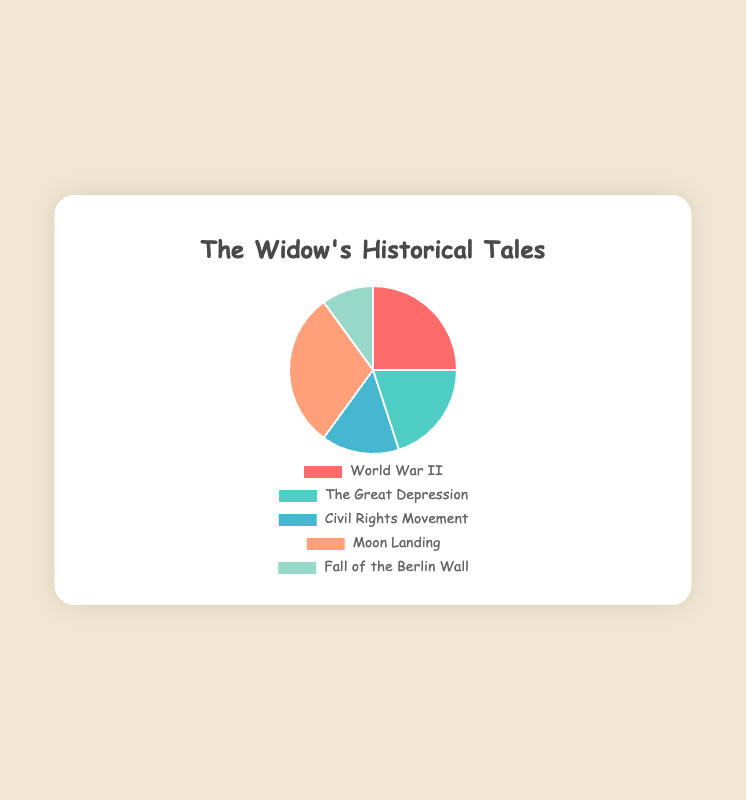Which historical event is most frequently discussed in the widow's stories? The figure shows a pie chart with the Moon Landing comprising the largest slice at 30%.
Answer: Moon Landing Which historical event is least frequently discussed in the widow's stories? The figure shows a pie chart with the Fall of the Berlin Wall comprising the smallest slice at 10%.
Answer: Fall of the Berlin Wall How much more frequently is the Moon Landing discussed compared to the Civil Rights Movement? The Moon Landing is 30% and the Civil Rights Movement is 15%. The difference is 30% - 15% = 15%.
Answer: 15% What is the combined percentage for stories about World War II and the Great Depression? World War II is 25% and the Great Depression is 20%. The combined percentage is 25% + 20% = 45%.
Answer: 45% Which two historical events are discussed equally, making up 50% of the stories? The Moon Landing is 30% and the Great Depression is 20%. Combined, they make 30% + 20% = 50%.
Answer: Moon Landing and Great Depression What is the average percentage of stories for all historical events? The percentages are 25%, 20%, 15%, 30%, and 10%. The sum is 100%. The average is 100% / 5 = 20%.
Answer: 20% How do the stories of the Civil Rights Movement compare to those of the Fall of the Berlin Wall in terms of frequency? The Civil Rights Movement is discussed 15% of the time, while the Fall of the Berlin Wall is discussed 10% of the time. The Civil Rights Movement is discussed more frequently by 5%.
Answer: Civil Rights Movement is 5% more Is the sum of the percentages for the stories about World War II and the Moon Landing greater than 50%? World War II is 25% and the Moon Landing is 30%. The sum is 25% + 30% = 55%, which is greater than 50%.
Answer: Yes What color represents the section for the Great Depression? The pie chart colors in order are: World War II (red), The Great Depression (teal green), Civil Rights Movement (blue), Moon Landing (light salmon), Fall of the Berlin Wall (pale green).
Answer: Teal green Which historical event's slice is a different color compared to ones around it? The Moon Landing’s slice is orange (light salmon) while World War II's slice is red and the Civil Rights Movement's slice is blue. These are different.
Answer: Moon Landing 